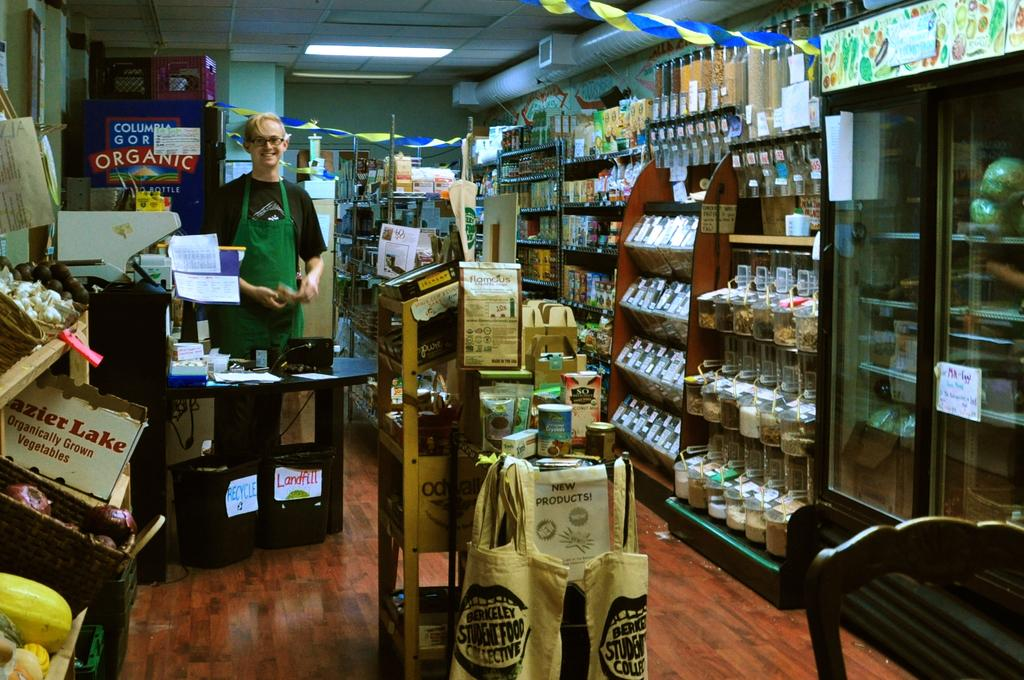Provide a one-sentence caption for the provided image. inside the general store with Berkeley student food bags hanging. 